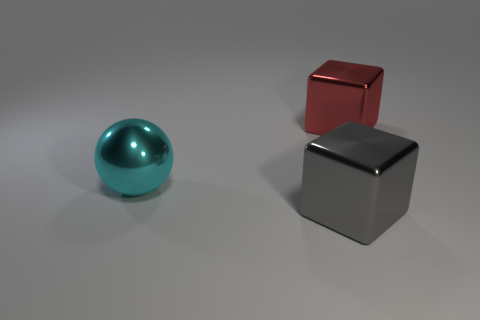Does the big cube to the right of the big gray shiny block have the same material as the gray block?
Your answer should be compact. Yes. Are there any gray metallic cubes that have the same size as the gray metal thing?
Make the answer very short. No. Does the cyan object have the same shape as the metallic thing that is in front of the large cyan thing?
Your answer should be compact. No. There is a large metal ball that is in front of the large red object to the right of the large gray metal object; are there any gray cubes on the left side of it?
Ensure brevity in your answer.  No. How big is the red object?
Keep it short and to the point. Large. How many other things are the same color as the big metal sphere?
Provide a succinct answer. 0. Do the thing that is in front of the big metallic sphere and the big cyan thing have the same shape?
Offer a terse response. No. There is another large shiny object that is the same shape as the large gray object; what color is it?
Keep it short and to the point. Red. Is there any other thing that has the same material as the cyan thing?
Provide a succinct answer. Yes. There is another metallic thing that is the same shape as the big red metal object; what is its size?
Your answer should be very brief. Large. 